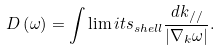Convert formula to latex. <formula><loc_0><loc_0><loc_500><loc_500>D \left ( \omega \right ) = \int \lim i t s _ { s h e l l } { \frac { { d k _ { / / } } } { { \left | { \nabla _ { k } \omega } \right | } } } .</formula> 